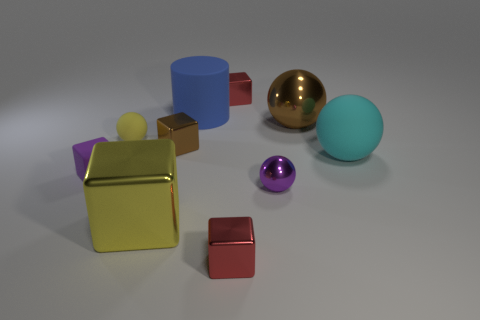There is a small red cube behind the big blue rubber thing on the left side of the big metallic ball; how many yellow matte things are to the right of it? After carefully reviewing the image, it is confirmed that there are no yellow matte objects to the right of the large metallic ball, nor elsewhere in the image. The composition comprises various geometric shapes with distinct colors and finishes, but a yellow matte item is not among them. 